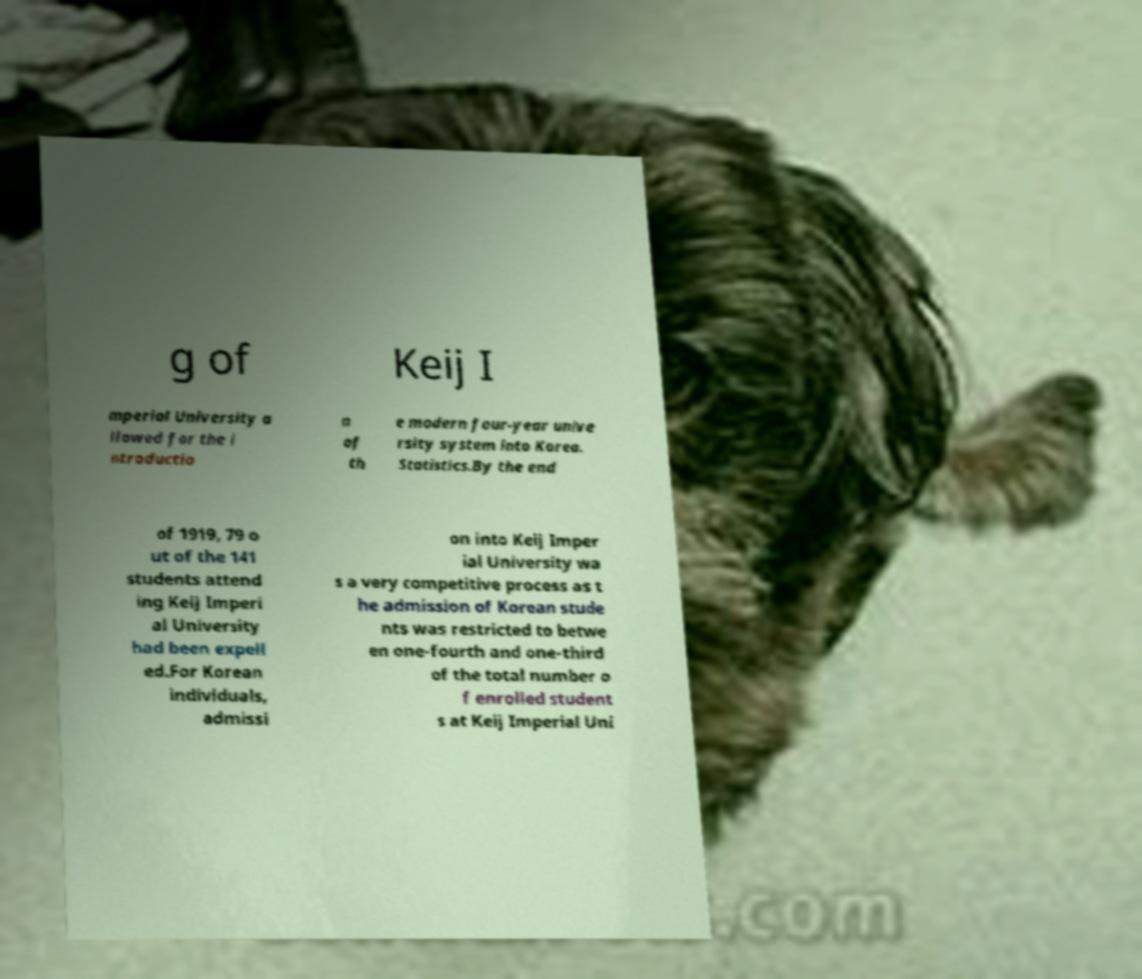I need the written content from this picture converted into text. Can you do that? g of Keij I mperial University a llowed for the i ntroductio n of th e modern four-year unive rsity system into Korea. Statistics.By the end of 1919, 79 o ut of the 141 students attend ing Keij Imperi al University had been expell ed.For Korean individuals, admissi on into Keij Imper ial University wa s a very competitive process as t he admission of Korean stude nts was restricted to betwe en one-fourth and one-third of the total number o f enrolled student s at Keij Imperial Uni 